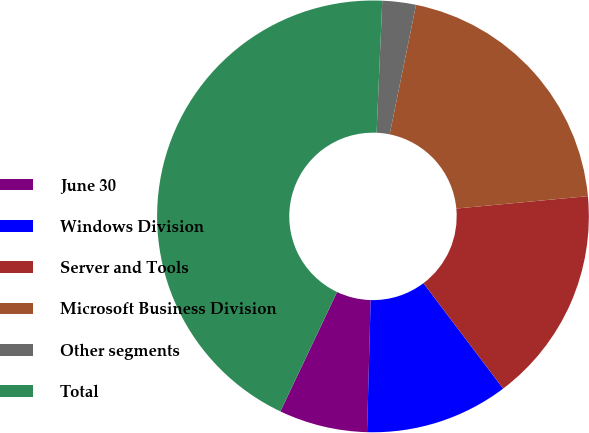Convert chart. <chart><loc_0><loc_0><loc_500><loc_500><pie_chart><fcel>June 30<fcel>Windows Division<fcel>Server and Tools<fcel>Microsoft Business Division<fcel>Other segments<fcel>Total<nl><fcel>6.62%<fcel>10.74%<fcel>16.19%<fcel>20.31%<fcel>2.51%<fcel>43.63%<nl></chart> 